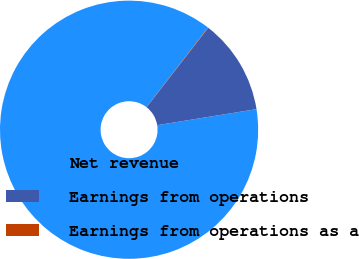<chart> <loc_0><loc_0><loc_500><loc_500><pie_chart><fcel>Net revenue<fcel>Earnings from operations<fcel>Earnings from operations as a<nl><fcel>88.01%<fcel>11.94%<fcel>0.05%<nl></chart> 